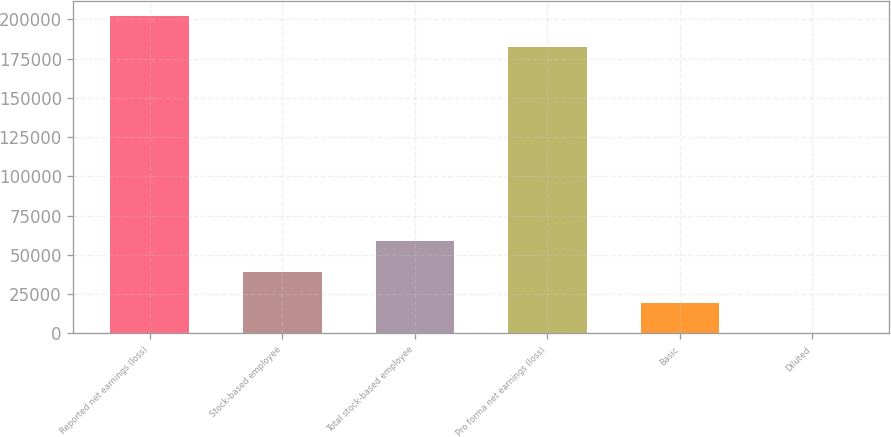<chart> <loc_0><loc_0><loc_500><loc_500><bar_chart><fcel>Reported net earnings (loss)<fcel>Stock-based employee<fcel>Total stock-based employee<fcel>Pro forma net earnings (loss)<fcel>Basic<fcel>Diluted<nl><fcel>201834<fcel>39196.2<fcel>58793.8<fcel>182236<fcel>19598.6<fcel>0.96<nl></chart> 